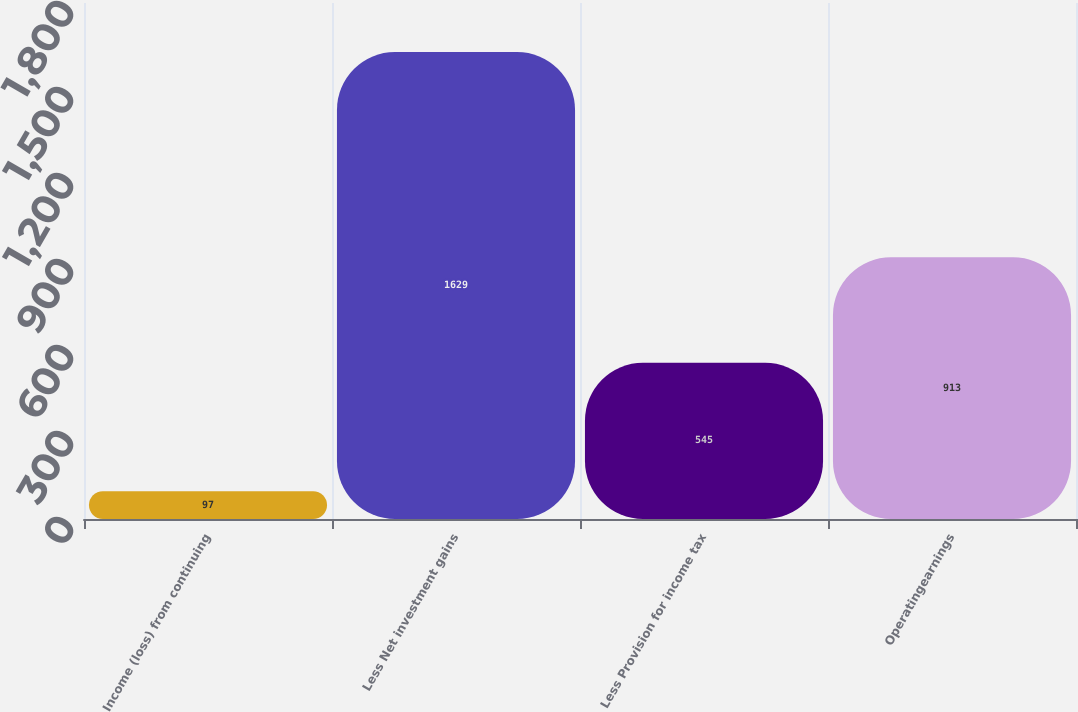Convert chart. <chart><loc_0><loc_0><loc_500><loc_500><bar_chart><fcel>Income (loss) from continuing<fcel>Less Net investment gains<fcel>Less Provision for income tax<fcel>Operatingearnings<nl><fcel>97<fcel>1629<fcel>545<fcel>913<nl></chart> 